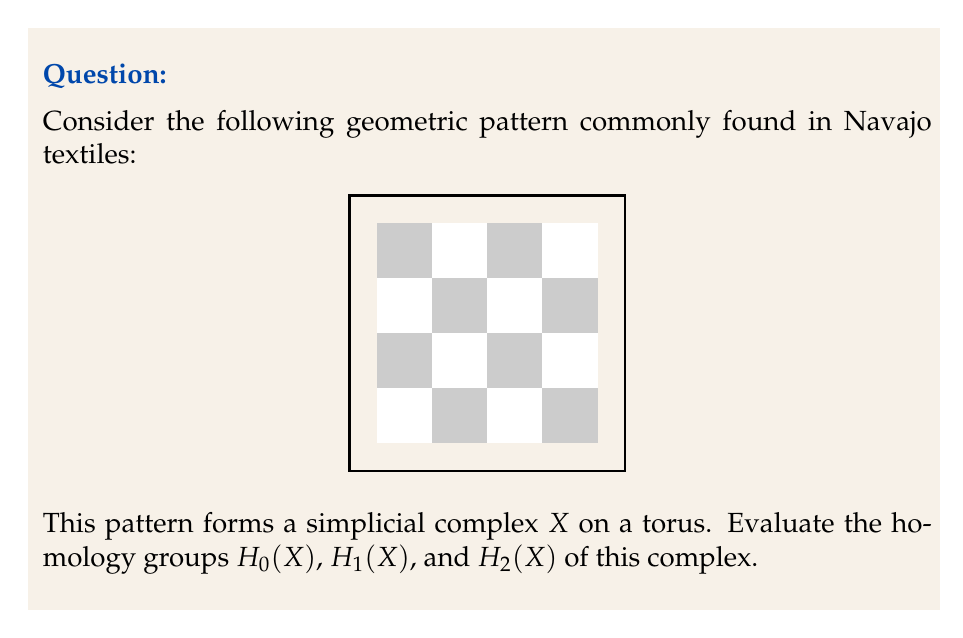Can you solve this math problem? To evaluate the homology groups of this simplicial complex, we'll follow these steps:

1) First, let's count the simplices:
   - 0-simplices (vertices): 16
   - 1-simplices (edges): 24
   - 2-simplices (faces): 8

2) Now, let's calculate the Euler characteristic:
   $\chi(X) = V - E + F = 16 - 24 + 8 = 0$

3) Since this complex is on a torus, we know that:
   - $H_0(X) \cong \mathbb{Z}$ (the complex is connected)
   - $H_2(X) \cong \mathbb{Z}$ (the complex is orientable and closed)

4) To find $H_1(X)$, we can use the Euler-Poincaré formula:
   $\chi(X) = \sum_{i=0}^2 (-1)^i \text{rank} H_i(X)$

5) Substituting what we know:
   $0 = 1 - \text{rank} H_1(X) + 1$

6) Solving for $\text{rank} H_1(X)$:
   $\text{rank} H_1(X) = 2$

7) Since we're working over $\mathbb{Z}$, this means:
   $H_1(X) \cong \mathbb{Z} \oplus \mathbb{Z}$

This result is consistent with the known homology groups of a torus.
Answer: $H_0(X) \cong \mathbb{Z}$, $H_1(X) \cong \mathbb{Z} \oplus \mathbb{Z}$, $H_2(X) \cong \mathbb{Z}$ 